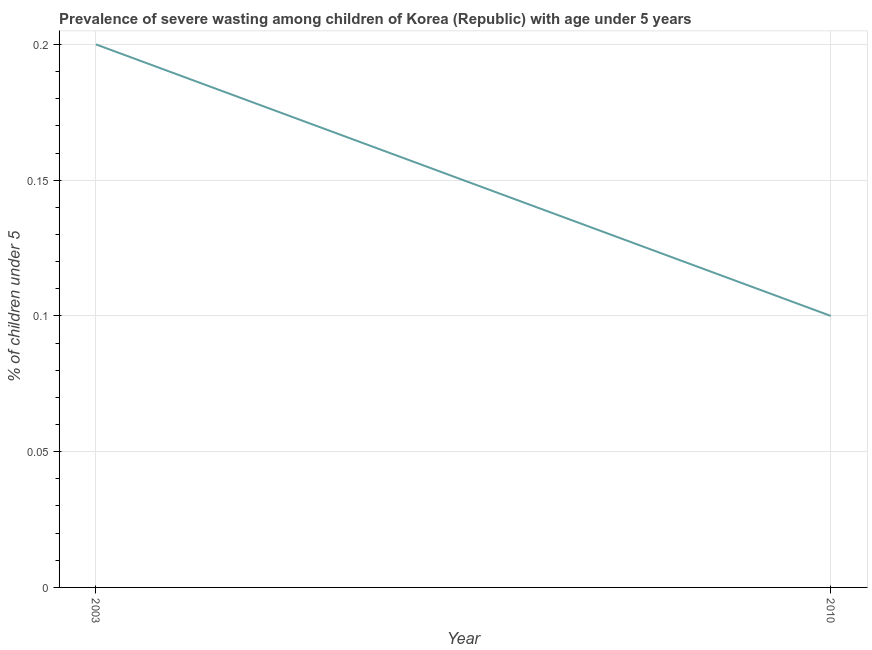What is the prevalence of severe wasting in 2010?
Provide a short and direct response. 0.1. Across all years, what is the maximum prevalence of severe wasting?
Offer a terse response. 0.2. Across all years, what is the minimum prevalence of severe wasting?
Provide a short and direct response. 0.1. In which year was the prevalence of severe wasting maximum?
Keep it short and to the point. 2003. In which year was the prevalence of severe wasting minimum?
Your answer should be very brief. 2010. What is the sum of the prevalence of severe wasting?
Your answer should be compact. 0.3. What is the difference between the prevalence of severe wasting in 2003 and 2010?
Your answer should be very brief. 0.1. What is the average prevalence of severe wasting per year?
Keep it short and to the point. 0.15. What is the median prevalence of severe wasting?
Make the answer very short. 0.15. In how many years, is the prevalence of severe wasting greater than 0.16000000000000003 %?
Ensure brevity in your answer.  1. In how many years, is the prevalence of severe wasting greater than the average prevalence of severe wasting taken over all years?
Keep it short and to the point. 1. Does the prevalence of severe wasting monotonically increase over the years?
Offer a terse response. No. How many lines are there?
Your answer should be compact. 1. How many years are there in the graph?
Offer a terse response. 2. What is the difference between two consecutive major ticks on the Y-axis?
Offer a terse response. 0.05. Does the graph contain grids?
Your response must be concise. Yes. What is the title of the graph?
Provide a succinct answer. Prevalence of severe wasting among children of Korea (Republic) with age under 5 years. What is the label or title of the X-axis?
Provide a succinct answer. Year. What is the label or title of the Y-axis?
Provide a short and direct response.  % of children under 5. What is the  % of children under 5 in 2003?
Your answer should be very brief. 0.2. What is the  % of children under 5 in 2010?
Give a very brief answer. 0.1. 